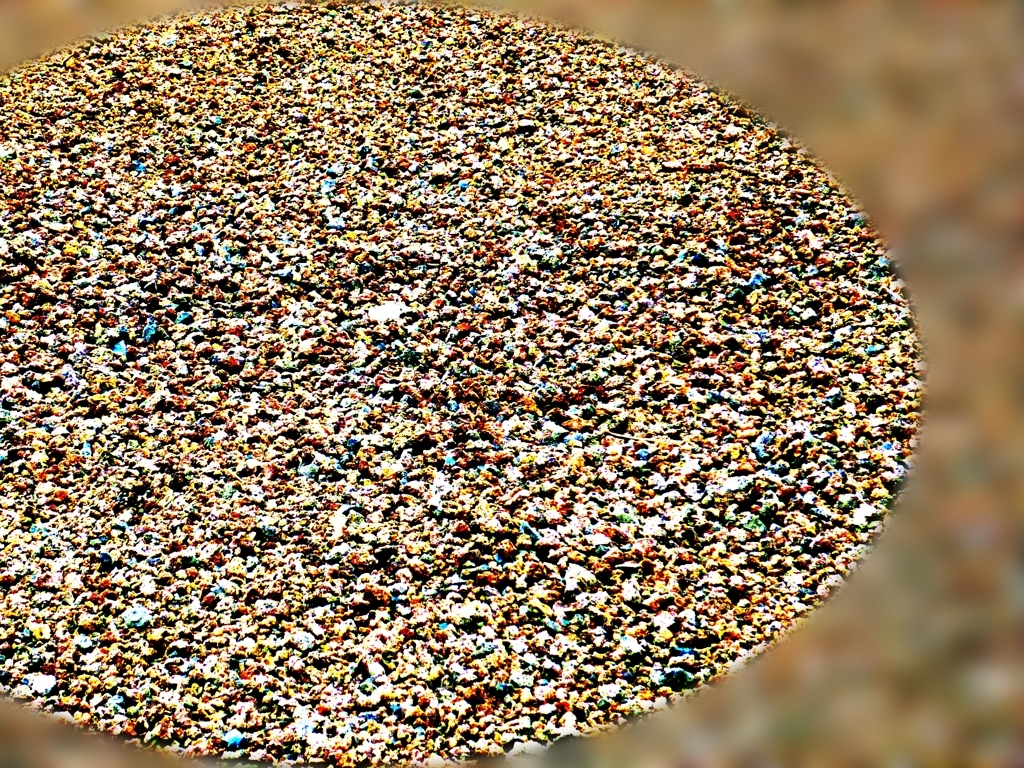Are the details and textures in the background easy to recognize? It's challenging to confidently discern the details and textures in the given image due to visual complexity or quality. The myriad of elements merge, causing a somewhat chaotic visual effect, and while there might be recognizable forms upon closer examination, initial perception may not yield clear and identifiable structures or patterns. 